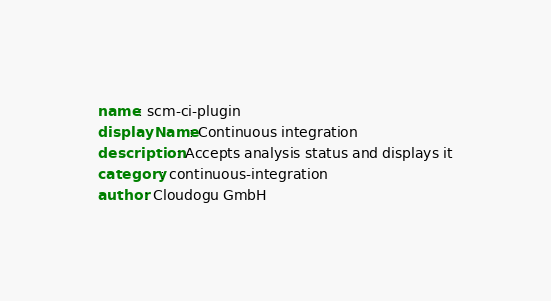<code> <loc_0><loc_0><loc_500><loc_500><_YAML_>name: scm-ci-plugin
displayName: Continuous integration
description: Accepts analysis status and displays it
category: continuous-integration
author: Cloudogu GmbH</code> 